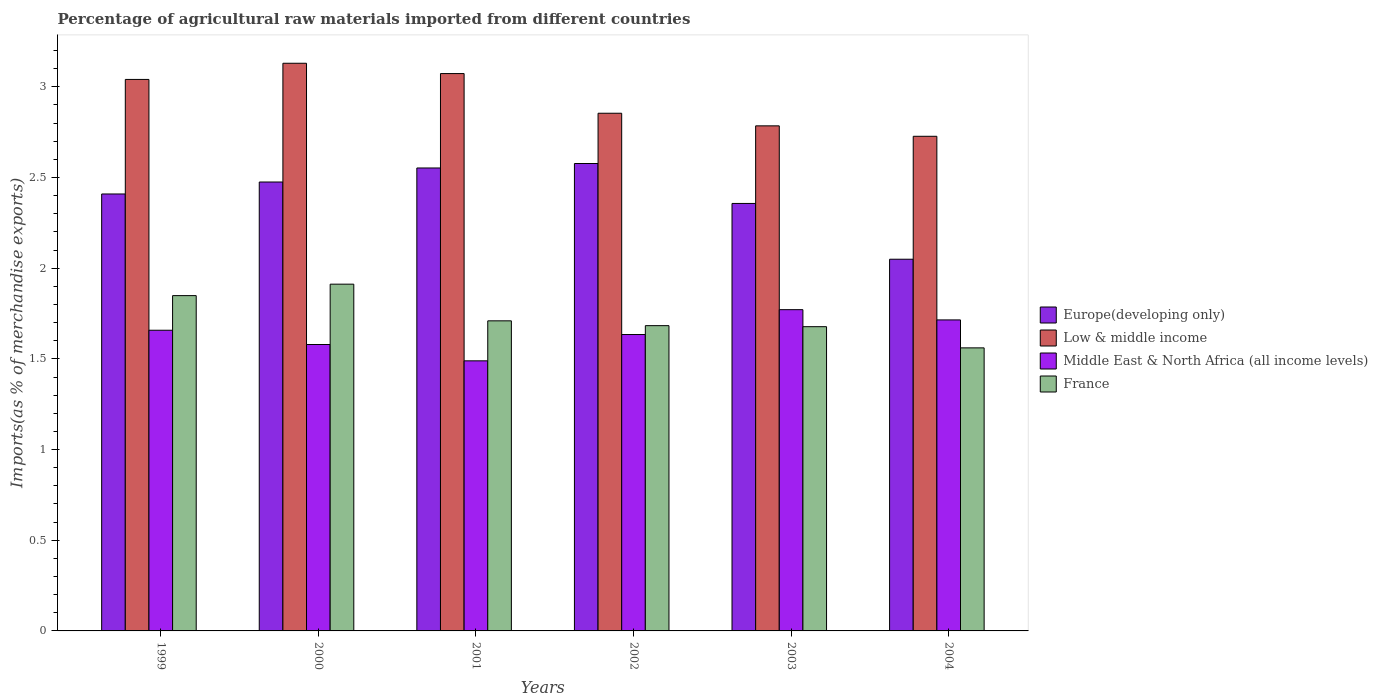Are the number of bars on each tick of the X-axis equal?
Provide a succinct answer. Yes. How many bars are there on the 5th tick from the left?
Keep it short and to the point. 4. How many bars are there on the 3rd tick from the right?
Give a very brief answer. 4. What is the label of the 3rd group of bars from the left?
Provide a short and direct response. 2001. In how many cases, is the number of bars for a given year not equal to the number of legend labels?
Make the answer very short. 0. What is the percentage of imports to different countries in Low & middle income in 2001?
Give a very brief answer. 3.07. Across all years, what is the maximum percentage of imports to different countries in Middle East & North Africa (all income levels)?
Provide a short and direct response. 1.77. Across all years, what is the minimum percentage of imports to different countries in Europe(developing only)?
Provide a short and direct response. 2.05. In which year was the percentage of imports to different countries in France maximum?
Make the answer very short. 2000. In which year was the percentage of imports to different countries in Middle East & North Africa (all income levels) minimum?
Ensure brevity in your answer.  2001. What is the total percentage of imports to different countries in France in the graph?
Provide a short and direct response. 10.39. What is the difference between the percentage of imports to different countries in Low & middle income in 2000 and that in 2001?
Give a very brief answer. 0.06. What is the difference between the percentage of imports to different countries in Europe(developing only) in 2001 and the percentage of imports to different countries in Low & middle income in 2004?
Your response must be concise. -0.17. What is the average percentage of imports to different countries in Low & middle income per year?
Your response must be concise. 2.93. In the year 2003, what is the difference between the percentage of imports to different countries in Middle East & North Africa (all income levels) and percentage of imports to different countries in Europe(developing only)?
Give a very brief answer. -0.59. In how many years, is the percentage of imports to different countries in Low & middle income greater than 2.2 %?
Your answer should be compact. 6. What is the ratio of the percentage of imports to different countries in Middle East & North Africa (all income levels) in 2001 to that in 2003?
Give a very brief answer. 0.84. Is the percentage of imports to different countries in Europe(developing only) in 2000 less than that in 2002?
Your answer should be very brief. Yes. Is the difference between the percentage of imports to different countries in Middle East & North Africa (all income levels) in 1999 and 2000 greater than the difference between the percentage of imports to different countries in Europe(developing only) in 1999 and 2000?
Offer a very short reply. Yes. What is the difference between the highest and the second highest percentage of imports to different countries in France?
Keep it short and to the point. 0.06. What is the difference between the highest and the lowest percentage of imports to different countries in Low & middle income?
Offer a terse response. 0.4. What does the 4th bar from the left in 2001 represents?
Your answer should be very brief. France. Are all the bars in the graph horizontal?
Provide a short and direct response. No. How many years are there in the graph?
Offer a very short reply. 6. What is the difference between two consecutive major ticks on the Y-axis?
Provide a short and direct response. 0.5. Are the values on the major ticks of Y-axis written in scientific E-notation?
Ensure brevity in your answer.  No. Does the graph contain grids?
Offer a very short reply. No. Where does the legend appear in the graph?
Provide a short and direct response. Center right. How are the legend labels stacked?
Keep it short and to the point. Vertical. What is the title of the graph?
Provide a short and direct response. Percentage of agricultural raw materials imported from different countries. Does "Jamaica" appear as one of the legend labels in the graph?
Provide a succinct answer. No. What is the label or title of the X-axis?
Your response must be concise. Years. What is the label or title of the Y-axis?
Give a very brief answer. Imports(as % of merchandise exports). What is the Imports(as % of merchandise exports) in Europe(developing only) in 1999?
Offer a very short reply. 2.41. What is the Imports(as % of merchandise exports) of Low & middle income in 1999?
Your response must be concise. 3.04. What is the Imports(as % of merchandise exports) of Middle East & North Africa (all income levels) in 1999?
Ensure brevity in your answer.  1.66. What is the Imports(as % of merchandise exports) in France in 1999?
Make the answer very short. 1.85. What is the Imports(as % of merchandise exports) of Europe(developing only) in 2000?
Offer a very short reply. 2.48. What is the Imports(as % of merchandise exports) of Low & middle income in 2000?
Make the answer very short. 3.13. What is the Imports(as % of merchandise exports) of Middle East & North Africa (all income levels) in 2000?
Offer a very short reply. 1.58. What is the Imports(as % of merchandise exports) in France in 2000?
Your answer should be very brief. 1.91. What is the Imports(as % of merchandise exports) of Europe(developing only) in 2001?
Offer a terse response. 2.55. What is the Imports(as % of merchandise exports) in Low & middle income in 2001?
Ensure brevity in your answer.  3.07. What is the Imports(as % of merchandise exports) of Middle East & North Africa (all income levels) in 2001?
Ensure brevity in your answer.  1.49. What is the Imports(as % of merchandise exports) in France in 2001?
Provide a succinct answer. 1.71. What is the Imports(as % of merchandise exports) in Europe(developing only) in 2002?
Keep it short and to the point. 2.58. What is the Imports(as % of merchandise exports) of Low & middle income in 2002?
Keep it short and to the point. 2.85. What is the Imports(as % of merchandise exports) of Middle East & North Africa (all income levels) in 2002?
Your response must be concise. 1.63. What is the Imports(as % of merchandise exports) in France in 2002?
Provide a short and direct response. 1.68. What is the Imports(as % of merchandise exports) of Europe(developing only) in 2003?
Make the answer very short. 2.36. What is the Imports(as % of merchandise exports) in Low & middle income in 2003?
Offer a terse response. 2.78. What is the Imports(as % of merchandise exports) in Middle East & North Africa (all income levels) in 2003?
Offer a very short reply. 1.77. What is the Imports(as % of merchandise exports) in France in 2003?
Give a very brief answer. 1.68. What is the Imports(as % of merchandise exports) in Europe(developing only) in 2004?
Provide a short and direct response. 2.05. What is the Imports(as % of merchandise exports) in Low & middle income in 2004?
Your response must be concise. 2.73. What is the Imports(as % of merchandise exports) of Middle East & North Africa (all income levels) in 2004?
Ensure brevity in your answer.  1.71. What is the Imports(as % of merchandise exports) in France in 2004?
Make the answer very short. 1.56. Across all years, what is the maximum Imports(as % of merchandise exports) in Europe(developing only)?
Your answer should be compact. 2.58. Across all years, what is the maximum Imports(as % of merchandise exports) in Low & middle income?
Provide a succinct answer. 3.13. Across all years, what is the maximum Imports(as % of merchandise exports) in Middle East & North Africa (all income levels)?
Your response must be concise. 1.77. Across all years, what is the maximum Imports(as % of merchandise exports) of France?
Your response must be concise. 1.91. Across all years, what is the minimum Imports(as % of merchandise exports) of Europe(developing only)?
Ensure brevity in your answer.  2.05. Across all years, what is the minimum Imports(as % of merchandise exports) in Low & middle income?
Your answer should be compact. 2.73. Across all years, what is the minimum Imports(as % of merchandise exports) in Middle East & North Africa (all income levels)?
Offer a terse response. 1.49. Across all years, what is the minimum Imports(as % of merchandise exports) in France?
Offer a very short reply. 1.56. What is the total Imports(as % of merchandise exports) of Europe(developing only) in the graph?
Provide a succinct answer. 14.42. What is the total Imports(as % of merchandise exports) in Low & middle income in the graph?
Your answer should be very brief. 17.61. What is the total Imports(as % of merchandise exports) in Middle East & North Africa (all income levels) in the graph?
Offer a very short reply. 9.85. What is the total Imports(as % of merchandise exports) of France in the graph?
Your response must be concise. 10.39. What is the difference between the Imports(as % of merchandise exports) of Europe(developing only) in 1999 and that in 2000?
Keep it short and to the point. -0.07. What is the difference between the Imports(as % of merchandise exports) in Low & middle income in 1999 and that in 2000?
Your response must be concise. -0.09. What is the difference between the Imports(as % of merchandise exports) of Middle East & North Africa (all income levels) in 1999 and that in 2000?
Provide a short and direct response. 0.08. What is the difference between the Imports(as % of merchandise exports) in France in 1999 and that in 2000?
Give a very brief answer. -0.06. What is the difference between the Imports(as % of merchandise exports) of Europe(developing only) in 1999 and that in 2001?
Offer a very short reply. -0.14. What is the difference between the Imports(as % of merchandise exports) of Low & middle income in 1999 and that in 2001?
Your response must be concise. -0.03. What is the difference between the Imports(as % of merchandise exports) in Middle East & North Africa (all income levels) in 1999 and that in 2001?
Your answer should be compact. 0.17. What is the difference between the Imports(as % of merchandise exports) of France in 1999 and that in 2001?
Keep it short and to the point. 0.14. What is the difference between the Imports(as % of merchandise exports) in Europe(developing only) in 1999 and that in 2002?
Make the answer very short. -0.17. What is the difference between the Imports(as % of merchandise exports) of Low & middle income in 1999 and that in 2002?
Your answer should be very brief. 0.19. What is the difference between the Imports(as % of merchandise exports) of Middle East & North Africa (all income levels) in 1999 and that in 2002?
Offer a terse response. 0.02. What is the difference between the Imports(as % of merchandise exports) of France in 1999 and that in 2002?
Keep it short and to the point. 0.17. What is the difference between the Imports(as % of merchandise exports) of Europe(developing only) in 1999 and that in 2003?
Keep it short and to the point. 0.05. What is the difference between the Imports(as % of merchandise exports) of Low & middle income in 1999 and that in 2003?
Provide a succinct answer. 0.26. What is the difference between the Imports(as % of merchandise exports) in Middle East & North Africa (all income levels) in 1999 and that in 2003?
Keep it short and to the point. -0.11. What is the difference between the Imports(as % of merchandise exports) of France in 1999 and that in 2003?
Keep it short and to the point. 0.17. What is the difference between the Imports(as % of merchandise exports) of Europe(developing only) in 1999 and that in 2004?
Ensure brevity in your answer.  0.36. What is the difference between the Imports(as % of merchandise exports) of Low & middle income in 1999 and that in 2004?
Your answer should be very brief. 0.31. What is the difference between the Imports(as % of merchandise exports) of Middle East & North Africa (all income levels) in 1999 and that in 2004?
Ensure brevity in your answer.  -0.06. What is the difference between the Imports(as % of merchandise exports) in France in 1999 and that in 2004?
Give a very brief answer. 0.29. What is the difference between the Imports(as % of merchandise exports) of Europe(developing only) in 2000 and that in 2001?
Ensure brevity in your answer.  -0.08. What is the difference between the Imports(as % of merchandise exports) of Low & middle income in 2000 and that in 2001?
Your response must be concise. 0.06. What is the difference between the Imports(as % of merchandise exports) in Middle East & North Africa (all income levels) in 2000 and that in 2001?
Offer a very short reply. 0.09. What is the difference between the Imports(as % of merchandise exports) of France in 2000 and that in 2001?
Your response must be concise. 0.2. What is the difference between the Imports(as % of merchandise exports) in Europe(developing only) in 2000 and that in 2002?
Keep it short and to the point. -0.1. What is the difference between the Imports(as % of merchandise exports) of Low & middle income in 2000 and that in 2002?
Make the answer very short. 0.28. What is the difference between the Imports(as % of merchandise exports) in Middle East & North Africa (all income levels) in 2000 and that in 2002?
Your answer should be compact. -0.06. What is the difference between the Imports(as % of merchandise exports) in France in 2000 and that in 2002?
Your answer should be compact. 0.23. What is the difference between the Imports(as % of merchandise exports) of Europe(developing only) in 2000 and that in 2003?
Your answer should be very brief. 0.12. What is the difference between the Imports(as % of merchandise exports) of Low & middle income in 2000 and that in 2003?
Provide a short and direct response. 0.35. What is the difference between the Imports(as % of merchandise exports) of Middle East & North Africa (all income levels) in 2000 and that in 2003?
Provide a succinct answer. -0.19. What is the difference between the Imports(as % of merchandise exports) in France in 2000 and that in 2003?
Your answer should be compact. 0.23. What is the difference between the Imports(as % of merchandise exports) of Europe(developing only) in 2000 and that in 2004?
Your answer should be compact. 0.43. What is the difference between the Imports(as % of merchandise exports) of Low & middle income in 2000 and that in 2004?
Provide a succinct answer. 0.4. What is the difference between the Imports(as % of merchandise exports) in Middle East & North Africa (all income levels) in 2000 and that in 2004?
Make the answer very short. -0.14. What is the difference between the Imports(as % of merchandise exports) of France in 2000 and that in 2004?
Offer a very short reply. 0.35. What is the difference between the Imports(as % of merchandise exports) of Europe(developing only) in 2001 and that in 2002?
Your answer should be compact. -0.02. What is the difference between the Imports(as % of merchandise exports) in Low & middle income in 2001 and that in 2002?
Make the answer very short. 0.22. What is the difference between the Imports(as % of merchandise exports) of Middle East & North Africa (all income levels) in 2001 and that in 2002?
Offer a very short reply. -0.15. What is the difference between the Imports(as % of merchandise exports) of France in 2001 and that in 2002?
Keep it short and to the point. 0.03. What is the difference between the Imports(as % of merchandise exports) in Europe(developing only) in 2001 and that in 2003?
Offer a terse response. 0.2. What is the difference between the Imports(as % of merchandise exports) of Low & middle income in 2001 and that in 2003?
Provide a succinct answer. 0.29. What is the difference between the Imports(as % of merchandise exports) in Middle East & North Africa (all income levels) in 2001 and that in 2003?
Your answer should be very brief. -0.28. What is the difference between the Imports(as % of merchandise exports) in France in 2001 and that in 2003?
Your answer should be compact. 0.03. What is the difference between the Imports(as % of merchandise exports) of Europe(developing only) in 2001 and that in 2004?
Your response must be concise. 0.5. What is the difference between the Imports(as % of merchandise exports) of Low & middle income in 2001 and that in 2004?
Offer a terse response. 0.35. What is the difference between the Imports(as % of merchandise exports) of Middle East & North Africa (all income levels) in 2001 and that in 2004?
Provide a short and direct response. -0.23. What is the difference between the Imports(as % of merchandise exports) of France in 2001 and that in 2004?
Give a very brief answer. 0.15. What is the difference between the Imports(as % of merchandise exports) of Europe(developing only) in 2002 and that in 2003?
Offer a very short reply. 0.22. What is the difference between the Imports(as % of merchandise exports) in Low & middle income in 2002 and that in 2003?
Offer a terse response. 0.07. What is the difference between the Imports(as % of merchandise exports) in Middle East & North Africa (all income levels) in 2002 and that in 2003?
Offer a very short reply. -0.14. What is the difference between the Imports(as % of merchandise exports) in France in 2002 and that in 2003?
Ensure brevity in your answer.  0.01. What is the difference between the Imports(as % of merchandise exports) in Europe(developing only) in 2002 and that in 2004?
Provide a succinct answer. 0.53. What is the difference between the Imports(as % of merchandise exports) in Low & middle income in 2002 and that in 2004?
Offer a very short reply. 0.13. What is the difference between the Imports(as % of merchandise exports) in Middle East & North Africa (all income levels) in 2002 and that in 2004?
Your response must be concise. -0.08. What is the difference between the Imports(as % of merchandise exports) of France in 2002 and that in 2004?
Ensure brevity in your answer.  0.12. What is the difference between the Imports(as % of merchandise exports) in Europe(developing only) in 2003 and that in 2004?
Your response must be concise. 0.31. What is the difference between the Imports(as % of merchandise exports) in Low & middle income in 2003 and that in 2004?
Provide a short and direct response. 0.06. What is the difference between the Imports(as % of merchandise exports) of Middle East & North Africa (all income levels) in 2003 and that in 2004?
Provide a succinct answer. 0.06. What is the difference between the Imports(as % of merchandise exports) of France in 2003 and that in 2004?
Your answer should be compact. 0.12. What is the difference between the Imports(as % of merchandise exports) of Europe(developing only) in 1999 and the Imports(as % of merchandise exports) of Low & middle income in 2000?
Your response must be concise. -0.72. What is the difference between the Imports(as % of merchandise exports) in Europe(developing only) in 1999 and the Imports(as % of merchandise exports) in Middle East & North Africa (all income levels) in 2000?
Keep it short and to the point. 0.83. What is the difference between the Imports(as % of merchandise exports) in Europe(developing only) in 1999 and the Imports(as % of merchandise exports) in France in 2000?
Provide a succinct answer. 0.5. What is the difference between the Imports(as % of merchandise exports) in Low & middle income in 1999 and the Imports(as % of merchandise exports) in Middle East & North Africa (all income levels) in 2000?
Your answer should be very brief. 1.46. What is the difference between the Imports(as % of merchandise exports) in Low & middle income in 1999 and the Imports(as % of merchandise exports) in France in 2000?
Offer a terse response. 1.13. What is the difference between the Imports(as % of merchandise exports) of Middle East & North Africa (all income levels) in 1999 and the Imports(as % of merchandise exports) of France in 2000?
Provide a succinct answer. -0.25. What is the difference between the Imports(as % of merchandise exports) of Europe(developing only) in 1999 and the Imports(as % of merchandise exports) of Low & middle income in 2001?
Offer a terse response. -0.66. What is the difference between the Imports(as % of merchandise exports) in Europe(developing only) in 1999 and the Imports(as % of merchandise exports) in Middle East & North Africa (all income levels) in 2001?
Your answer should be compact. 0.92. What is the difference between the Imports(as % of merchandise exports) in Europe(developing only) in 1999 and the Imports(as % of merchandise exports) in France in 2001?
Your answer should be very brief. 0.7. What is the difference between the Imports(as % of merchandise exports) of Low & middle income in 1999 and the Imports(as % of merchandise exports) of Middle East & North Africa (all income levels) in 2001?
Offer a very short reply. 1.55. What is the difference between the Imports(as % of merchandise exports) of Low & middle income in 1999 and the Imports(as % of merchandise exports) of France in 2001?
Give a very brief answer. 1.33. What is the difference between the Imports(as % of merchandise exports) of Middle East & North Africa (all income levels) in 1999 and the Imports(as % of merchandise exports) of France in 2001?
Provide a succinct answer. -0.05. What is the difference between the Imports(as % of merchandise exports) of Europe(developing only) in 1999 and the Imports(as % of merchandise exports) of Low & middle income in 2002?
Provide a succinct answer. -0.45. What is the difference between the Imports(as % of merchandise exports) of Europe(developing only) in 1999 and the Imports(as % of merchandise exports) of Middle East & North Africa (all income levels) in 2002?
Provide a succinct answer. 0.77. What is the difference between the Imports(as % of merchandise exports) of Europe(developing only) in 1999 and the Imports(as % of merchandise exports) of France in 2002?
Keep it short and to the point. 0.73. What is the difference between the Imports(as % of merchandise exports) of Low & middle income in 1999 and the Imports(as % of merchandise exports) of Middle East & North Africa (all income levels) in 2002?
Keep it short and to the point. 1.41. What is the difference between the Imports(as % of merchandise exports) of Low & middle income in 1999 and the Imports(as % of merchandise exports) of France in 2002?
Offer a terse response. 1.36. What is the difference between the Imports(as % of merchandise exports) in Middle East & North Africa (all income levels) in 1999 and the Imports(as % of merchandise exports) in France in 2002?
Make the answer very short. -0.03. What is the difference between the Imports(as % of merchandise exports) of Europe(developing only) in 1999 and the Imports(as % of merchandise exports) of Low & middle income in 2003?
Ensure brevity in your answer.  -0.38. What is the difference between the Imports(as % of merchandise exports) of Europe(developing only) in 1999 and the Imports(as % of merchandise exports) of Middle East & North Africa (all income levels) in 2003?
Keep it short and to the point. 0.64. What is the difference between the Imports(as % of merchandise exports) in Europe(developing only) in 1999 and the Imports(as % of merchandise exports) in France in 2003?
Your answer should be very brief. 0.73. What is the difference between the Imports(as % of merchandise exports) in Low & middle income in 1999 and the Imports(as % of merchandise exports) in Middle East & North Africa (all income levels) in 2003?
Offer a very short reply. 1.27. What is the difference between the Imports(as % of merchandise exports) in Low & middle income in 1999 and the Imports(as % of merchandise exports) in France in 2003?
Provide a short and direct response. 1.36. What is the difference between the Imports(as % of merchandise exports) of Middle East & North Africa (all income levels) in 1999 and the Imports(as % of merchandise exports) of France in 2003?
Your answer should be compact. -0.02. What is the difference between the Imports(as % of merchandise exports) of Europe(developing only) in 1999 and the Imports(as % of merchandise exports) of Low & middle income in 2004?
Provide a succinct answer. -0.32. What is the difference between the Imports(as % of merchandise exports) in Europe(developing only) in 1999 and the Imports(as % of merchandise exports) in Middle East & North Africa (all income levels) in 2004?
Give a very brief answer. 0.69. What is the difference between the Imports(as % of merchandise exports) in Europe(developing only) in 1999 and the Imports(as % of merchandise exports) in France in 2004?
Provide a succinct answer. 0.85. What is the difference between the Imports(as % of merchandise exports) of Low & middle income in 1999 and the Imports(as % of merchandise exports) of Middle East & North Africa (all income levels) in 2004?
Offer a very short reply. 1.33. What is the difference between the Imports(as % of merchandise exports) of Low & middle income in 1999 and the Imports(as % of merchandise exports) of France in 2004?
Offer a terse response. 1.48. What is the difference between the Imports(as % of merchandise exports) of Middle East & North Africa (all income levels) in 1999 and the Imports(as % of merchandise exports) of France in 2004?
Provide a short and direct response. 0.1. What is the difference between the Imports(as % of merchandise exports) in Europe(developing only) in 2000 and the Imports(as % of merchandise exports) in Low & middle income in 2001?
Your answer should be very brief. -0.6. What is the difference between the Imports(as % of merchandise exports) of Europe(developing only) in 2000 and the Imports(as % of merchandise exports) of Middle East & North Africa (all income levels) in 2001?
Provide a succinct answer. 0.99. What is the difference between the Imports(as % of merchandise exports) of Europe(developing only) in 2000 and the Imports(as % of merchandise exports) of France in 2001?
Your answer should be very brief. 0.77. What is the difference between the Imports(as % of merchandise exports) in Low & middle income in 2000 and the Imports(as % of merchandise exports) in Middle East & North Africa (all income levels) in 2001?
Provide a succinct answer. 1.64. What is the difference between the Imports(as % of merchandise exports) in Low & middle income in 2000 and the Imports(as % of merchandise exports) in France in 2001?
Keep it short and to the point. 1.42. What is the difference between the Imports(as % of merchandise exports) of Middle East & North Africa (all income levels) in 2000 and the Imports(as % of merchandise exports) of France in 2001?
Provide a succinct answer. -0.13. What is the difference between the Imports(as % of merchandise exports) in Europe(developing only) in 2000 and the Imports(as % of merchandise exports) in Low & middle income in 2002?
Give a very brief answer. -0.38. What is the difference between the Imports(as % of merchandise exports) in Europe(developing only) in 2000 and the Imports(as % of merchandise exports) in Middle East & North Africa (all income levels) in 2002?
Offer a terse response. 0.84. What is the difference between the Imports(as % of merchandise exports) of Europe(developing only) in 2000 and the Imports(as % of merchandise exports) of France in 2002?
Your answer should be very brief. 0.79. What is the difference between the Imports(as % of merchandise exports) in Low & middle income in 2000 and the Imports(as % of merchandise exports) in Middle East & North Africa (all income levels) in 2002?
Your answer should be very brief. 1.5. What is the difference between the Imports(as % of merchandise exports) of Low & middle income in 2000 and the Imports(as % of merchandise exports) of France in 2002?
Your answer should be compact. 1.45. What is the difference between the Imports(as % of merchandise exports) in Middle East & North Africa (all income levels) in 2000 and the Imports(as % of merchandise exports) in France in 2002?
Provide a succinct answer. -0.1. What is the difference between the Imports(as % of merchandise exports) in Europe(developing only) in 2000 and the Imports(as % of merchandise exports) in Low & middle income in 2003?
Your answer should be compact. -0.31. What is the difference between the Imports(as % of merchandise exports) of Europe(developing only) in 2000 and the Imports(as % of merchandise exports) of Middle East & North Africa (all income levels) in 2003?
Offer a terse response. 0.7. What is the difference between the Imports(as % of merchandise exports) in Europe(developing only) in 2000 and the Imports(as % of merchandise exports) in France in 2003?
Your response must be concise. 0.8. What is the difference between the Imports(as % of merchandise exports) of Low & middle income in 2000 and the Imports(as % of merchandise exports) of Middle East & North Africa (all income levels) in 2003?
Your response must be concise. 1.36. What is the difference between the Imports(as % of merchandise exports) of Low & middle income in 2000 and the Imports(as % of merchandise exports) of France in 2003?
Make the answer very short. 1.45. What is the difference between the Imports(as % of merchandise exports) of Middle East & North Africa (all income levels) in 2000 and the Imports(as % of merchandise exports) of France in 2003?
Offer a terse response. -0.1. What is the difference between the Imports(as % of merchandise exports) of Europe(developing only) in 2000 and the Imports(as % of merchandise exports) of Low & middle income in 2004?
Ensure brevity in your answer.  -0.25. What is the difference between the Imports(as % of merchandise exports) in Europe(developing only) in 2000 and the Imports(as % of merchandise exports) in Middle East & North Africa (all income levels) in 2004?
Give a very brief answer. 0.76. What is the difference between the Imports(as % of merchandise exports) in Europe(developing only) in 2000 and the Imports(as % of merchandise exports) in France in 2004?
Give a very brief answer. 0.91. What is the difference between the Imports(as % of merchandise exports) in Low & middle income in 2000 and the Imports(as % of merchandise exports) in Middle East & North Africa (all income levels) in 2004?
Keep it short and to the point. 1.42. What is the difference between the Imports(as % of merchandise exports) of Low & middle income in 2000 and the Imports(as % of merchandise exports) of France in 2004?
Offer a very short reply. 1.57. What is the difference between the Imports(as % of merchandise exports) of Middle East & North Africa (all income levels) in 2000 and the Imports(as % of merchandise exports) of France in 2004?
Ensure brevity in your answer.  0.02. What is the difference between the Imports(as % of merchandise exports) in Europe(developing only) in 2001 and the Imports(as % of merchandise exports) in Low & middle income in 2002?
Provide a short and direct response. -0.3. What is the difference between the Imports(as % of merchandise exports) in Europe(developing only) in 2001 and the Imports(as % of merchandise exports) in Middle East & North Africa (all income levels) in 2002?
Your answer should be compact. 0.92. What is the difference between the Imports(as % of merchandise exports) of Europe(developing only) in 2001 and the Imports(as % of merchandise exports) of France in 2002?
Your response must be concise. 0.87. What is the difference between the Imports(as % of merchandise exports) in Low & middle income in 2001 and the Imports(as % of merchandise exports) in Middle East & North Africa (all income levels) in 2002?
Keep it short and to the point. 1.44. What is the difference between the Imports(as % of merchandise exports) of Low & middle income in 2001 and the Imports(as % of merchandise exports) of France in 2002?
Provide a short and direct response. 1.39. What is the difference between the Imports(as % of merchandise exports) of Middle East & North Africa (all income levels) in 2001 and the Imports(as % of merchandise exports) of France in 2002?
Ensure brevity in your answer.  -0.19. What is the difference between the Imports(as % of merchandise exports) of Europe(developing only) in 2001 and the Imports(as % of merchandise exports) of Low & middle income in 2003?
Offer a very short reply. -0.23. What is the difference between the Imports(as % of merchandise exports) of Europe(developing only) in 2001 and the Imports(as % of merchandise exports) of Middle East & North Africa (all income levels) in 2003?
Keep it short and to the point. 0.78. What is the difference between the Imports(as % of merchandise exports) in Low & middle income in 2001 and the Imports(as % of merchandise exports) in Middle East & North Africa (all income levels) in 2003?
Your answer should be very brief. 1.3. What is the difference between the Imports(as % of merchandise exports) of Low & middle income in 2001 and the Imports(as % of merchandise exports) of France in 2003?
Keep it short and to the point. 1.4. What is the difference between the Imports(as % of merchandise exports) of Middle East & North Africa (all income levels) in 2001 and the Imports(as % of merchandise exports) of France in 2003?
Keep it short and to the point. -0.19. What is the difference between the Imports(as % of merchandise exports) of Europe(developing only) in 2001 and the Imports(as % of merchandise exports) of Low & middle income in 2004?
Make the answer very short. -0.17. What is the difference between the Imports(as % of merchandise exports) of Europe(developing only) in 2001 and the Imports(as % of merchandise exports) of Middle East & North Africa (all income levels) in 2004?
Your answer should be compact. 0.84. What is the difference between the Imports(as % of merchandise exports) of Europe(developing only) in 2001 and the Imports(as % of merchandise exports) of France in 2004?
Provide a short and direct response. 0.99. What is the difference between the Imports(as % of merchandise exports) of Low & middle income in 2001 and the Imports(as % of merchandise exports) of Middle East & North Africa (all income levels) in 2004?
Provide a short and direct response. 1.36. What is the difference between the Imports(as % of merchandise exports) of Low & middle income in 2001 and the Imports(as % of merchandise exports) of France in 2004?
Ensure brevity in your answer.  1.51. What is the difference between the Imports(as % of merchandise exports) of Middle East & North Africa (all income levels) in 2001 and the Imports(as % of merchandise exports) of France in 2004?
Make the answer very short. -0.07. What is the difference between the Imports(as % of merchandise exports) in Europe(developing only) in 2002 and the Imports(as % of merchandise exports) in Low & middle income in 2003?
Provide a short and direct response. -0.21. What is the difference between the Imports(as % of merchandise exports) of Europe(developing only) in 2002 and the Imports(as % of merchandise exports) of Middle East & North Africa (all income levels) in 2003?
Keep it short and to the point. 0.81. What is the difference between the Imports(as % of merchandise exports) of Europe(developing only) in 2002 and the Imports(as % of merchandise exports) of France in 2003?
Offer a very short reply. 0.9. What is the difference between the Imports(as % of merchandise exports) in Low & middle income in 2002 and the Imports(as % of merchandise exports) in Middle East & North Africa (all income levels) in 2003?
Keep it short and to the point. 1.08. What is the difference between the Imports(as % of merchandise exports) in Low & middle income in 2002 and the Imports(as % of merchandise exports) in France in 2003?
Provide a short and direct response. 1.18. What is the difference between the Imports(as % of merchandise exports) in Middle East & North Africa (all income levels) in 2002 and the Imports(as % of merchandise exports) in France in 2003?
Keep it short and to the point. -0.04. What is the difference between the Imports(as % of merchandise exports) in Europe(developing only) in 2002 and the Imports(as % of merchandise exports) in Low & middle income in 2004?
Your answer should be compact. -0.15. What is the difference between the Imports(as % of merchandise exports) of Europe(developing only) in 2002 and the Imports(as % of merchandise exports) of Middle East & North Africa (all income levels) in 2004?
Ensure brevity in your answer.  0.86. What is the difference between the Imports(as % of merchandise exports) in Europe(developing only) in 2002 and the Imports(as % of merchandise exports) in France in 2004?
Your answer should be very brief. 1.02. What is the difference between the Imports(as % of merchandise exports) in Low & middle income in 2002 and the Imports(as % of merchandise exports) in Middle East & North Africa (all income levels) in 2004?
Ensure brevity in your answer.  1.14. What is the difference between the Imports(as % of merchandise exports) in Low & middle income in 2002 and the Imports(as % of merchandise exports) in France in 2004?
Offer a very short reply. 1.29. What is the difference between the Imports(as % of merchandise exports) of Middle East & North Africa (all income levels) in 2002 and the Imports(as % of merchandise exports) of France in 2004?
Offer a very short reply. 0.07. What is the difference between the Imports(as % of merchandise exports) in Europe(developing only) in 2003 and the Imports(as % of merchandise exports) in Low & middle income in 2004?
Your response must be concise. -0.37. What is the difference between the Imports(as % of merchandise exports) in Europe(developing only) in 2003 and the Imports(as % of merchandise exports) in Middle East & North Africa (all income levels) in 2004?
Keep it short and to the point. 0.64. What is the difference between the Imports(as % of merchandise exports) in Europe(developing only) in 2003 and the Imports(as % of merchandise exports) in France in 2004?
Your answer should be very brief. 0.8. What is the difference between the Imports(as % of merchandise exports) of Low & middle income in 2003 and the Imports(as % of merchandise exports) of Middle East & North Africa (all income levels) in 2004?
Provide a short and direct response. 1.07. What is the difference between the Imports(as % of merchandise exports) of Low & middle income in 2003 and the Imports(as % of merchandise exports) of France in 2004?
Keep it short and to the point. 1.22. What is the difference between the Imports(as % of merchandise exports) in Middle East & North Africa (all income levels) in 2003 and the Imports(as % of merchandise exports) in France in 2004?
Offer a terse response. 0.21. What is the average Imports(as % of merchandise exports) in Europe(developing only) per year?
Ensure brevity in your answer.  2.4. What is the average Imports(as % of merchandise exports) in Low & middle income per year?
Your answer should be very brief. 2.94. What is the average Imports(as % of merchandise exports) of Middle East & North Africa (all income levels) per year?
Your response must be concise. 1.64. What is the average Imports(as % of merchandise exports) of France per year?
Your response must be concise. 1.73. In the year 1999, what is the difference between the Imports(as % of merchandise exports) of Europe(developing only) and Imports(as % of merchandise exports) of Low & middle income?
Give a very brief answer. -0.63. In the year 1999, what is the difference between the Imports(as % of merchandise exports) in Europe(developing only) and Imports(as % of merchandise exports) in Middle East & North Africa (all income levels)?
Your response must be concise. 0.75. In the year 1999, what is the difference between the Imports(as % of merchandise exports) of Europe(developing only) and Imports(as % of merchandise exports) of France?
Your response must be concise. 0.56. In the year 1999, what is the difference between the Imports(as % of merchandise exports) of Low & middle income and Imports(as % of merchandise exports) of Middle East & North Africa (all income levels)?
Your answer should be compact. 1.38. In the year 1999, what is the difference between the Imports(as % of merchandise exports) of Low & middle income and Imports(as % of merchandise exports) of France?
Offer a very short reply. 1.19. In the year 1999, what is the difference between the Imports(as % of merchandise exports) of Middle East & North Africa (all income levels) and Imports(as % of merchandise exports) of France?
Give a very brief answer. -0.19. In the year 2000, what is the difference between the Imports(as % of merchandise exports) of Europe(developing only) and Imports(as % of merchandise exports) of Low & middle income?
Give a very brief answer. -0.65. In the year 2000, what is the difference between the Imports(as % of merchandise exports) in Europe(developing only) and Imports(as % of merchandise exports) in Middle East & North Africa (all income levels)?
Give a very brief answer. 0.9. In the year 2000, what is the difference between the Imports(as % of merchandise exports) in Europe(developing only) and Imports(as % of merchandise exports) in France?
Ensure brevity in your answer.  0.56. In the year 2000, what is the difference between the Imports(as % of merchandise exports) of Low & middle income and Imports(as % of merchandise exports) of Middle East & North Africa (all income levels)?
Keep it short and to the point. 1.55. In the year 2000, what is the difference between the Imports(as % of merchandise exports) of Low & middle income and Imports(as % of merchandise exports) of France?
Your answer should be compact. 1.22. In the year 2000, what is the difference between the Imports(as % of merchandise exports) in Middle East & North Africa (all income levels) and Imports(as % of merchandise exports) in France?
Offer a very short reply. -0.33. In the year 2001, what is the difference between the Imports(as % of merchandise exports) in Europe(developing only) and Imports(as % of merchandise exports) in Low & middle income?
Provide a short and direct response. -0.52. In the year 2001, what is the difference between the Imports(as % of merchandise exports) of Europe(developing only) and Imports(as % of merchandise exports) of Middle East & North Africa (all income levels)?
Provide a short and direct response. 1.06. In the year 2001, what is the difference between the Imports(as % of merchandise exports) of Europe(developing only) and Imports(as % of merchandise exports) of France?
Your answer should be very brief. 0.84. In the year 2001, what is the difference between the Imports(as % of merchandise exports) of Low & middle income and Imports(as % of merchandise exports) of Middle East & North Africa (all income levels)?
Your response must be concise. 1.58. In the year 2001, what is the difference between the Imports(as % of merchandise exports) of Low & middle income and Imports(as % of merchandise exports) of France?
Your response must be concise. 1.36. In the year 2001, what is the difference between the Imports(as % of merchandise exports) of Middle East & North Africa (all income levels) and Imports(as % of merchandise exports) of France?
Offer a terse response. -0.22. In the year 2002, what is the difference between the Imports(as % of merchandise exports) of Europe(developing only) and Imports(as % of merchandise exports) of Low & middle income?
Your response must be concise. -0.28. In the year 2002, what is the difference between the Imports(as % of merchandise exports) of Europe(developing only) and Imports(as % of merchandise exports) of Middle East & North Africa (all income levels)?
Your answer should be compact. 0.94. In the year 2002, what is the difference between the Imports(as % of merchandise exports) of Europe(developing only) and Imports(as % of merchandise exports) of France?
Provide a succinct answer. 0.89. In the year 2002, what is the difference between the Imports(as % of merchandise exports) of Low & middle income and Imports(as % of merchandise exports) of Middle East & North Africa (all income levels)?
Ensure brevity in your answer.  1.22. In the year 2002, what is the difference between the Imports(as % of merchandise exports) in Low & middle income and Imports(as % of merchandise exports) in France?
Make the answer very short. 1.17. In the year 2002, what is the difference between the Imports(as % of merchandise exports) of Middle East & North Africa (all income levels) and Imports(as % of merchandise exports) of France?
Your answer should be compact. -0.05. In the year 2003, what is the difference between the Imports(as % of merchandise exports) in Europe(developing only) and Imports(as % of merchandise exports) in Low & middle income?
Offer a terse response. -0.43. In the year 2003, what is the difference between the Imports(as % of merchandise exports) in Europe(developing only) and Imports(as % of merchandise exports) in Middle East & North Africa (all income levels)?
Your answer should be compact. 0.59. In the year 2003, what is the difference between the Imports(as % of merchandise exports) of Europe(developing only) and Imports(as % of merchandise exports) of France?
Your answer should be very brief. 0.68. In the year 2003, what is the difference between the Imports(as % of merchandise exports) in Low & middle income and Imports(as % of merchandise exports) in Middle East & North Africa (all income levels)?
Your response must be concise. 1.01. In the year 2003, what is the difference between the Imports(as % of merchandise exports) of Low & middle income and Imports(as % of merchandise exports) of France?
Offer a terse response. 1.11. In the year 2003, what is the difference between the Imports(as % of merchandise exports) in Middle East & North Africa (all income levels) and Imports(as % of merchandise exports) in France?
Keep it short and to the point. 0.09. In the year 2004, what is the difference between the Imports(as % of merchandise exports) in Europe(developing only) and Imports(as % of merchandise exports) in Low & middle income?
Make the answer very short. -0.68. In the year 2004, what is the difference between the Imports(as % of merchandise exports) of Europe(developing only) and Imports(as % of merchandise exports) of Middle East & North Africa (all income levels)?
Your answer should be very brief. 0.33. In the year 2004, what is the difference between the Imports(as % of merchandise exports) in Europe(developing only) and Imports(as % of merchandise exports) in France?
Your answer should be compact. 0.49. In the year 2004, what is the difference between the Imports(as % of merchandise exports) of Low & middle income and Imports(as % of merchandise exports) of Middle East & North Africa (all income levels)?
Provide a succinct answer. 1.01. In the year 2004, what is the difference between the Imports(as % of merchandise exports) in Low & middle income and Imports(as % of merchandise exports) in France?
Offer a terse response. 1.17. In the year 2004, what is the difference between the Imports(as % of merchandise exports) of Middle East & North Africa (all income levels) and Imports(as % of merchandise exports) of France?
Your answer should be compact. 0.15. What is the ratio of the Imports(as % of merchandise exports) of Europe(developing only) in 1999 to that in 2000?
Offer a very short reply. 0.97. What is the ratio of the Imports(as % of merchandise exports) in Low & middle income in 1999 to that in 2000?
Give a very brief answer. 0.97. What is the ratio of the Imports(as % of merchandise exports) in Middle East & North Africa (all income levels) in 1999 to that in 2000?
Provide a succinct answer. 1.05. What is the ratio of the Imports(as % of merchandise exports) of Europe(developing only) in 1999 to that in 2001?
Provide a short and direct response. 0.94. What is the ratio of the Imports(as % of merchandise exports) of Low & middle income in 1999 to that in 2001?
Make the answer very short. 0.99. What is the ratio of the Imports(as % of merchandise exports) of Middle East & North Africa (all income levels) in 1999 to that in 2001?
Offer a terse response. 1.11. What is the ratio of the Imports(as % of merchandise exports) in France in 1999 to that in 2001?
Ensure brevity in your answer.  1.08. What is the ratio of the Imports(as % of merchandise exports) of Europe(developing only) in 1999 to that in 2002?
Give a very brief answer. 0.93. What is the ratio of the Imports(as % of merchandise exports) in Low & middle income in 1999 to that in 2002?
Your answer should be very brief. 1.07. What is the ratio of the Imports(as % of merchandise exports) in Middle East & North Africa (all income levels) in 1999 to that in 2002?
Your response must be concise. 1.01. What is the ratio of the Imports(as % of merchandise exports) of France in 1999 to that in 2002?
Offer a very short reply. 1.1. What is the ratio of the Imports(as % of merchandise exports) in Europe(developing only) in 1999 to that in 2003?
Offer a very short reply. 1.02. What is the ratio of the Imports(as % of merchandise exports) of Low & middle income in 1999 to that in 2003?
Give a very brief answer. 1.09. What is the ratio of the Imports(as % of merchandise exports) of Middle East & North Africa (all income levels) in 1999 to that in 2003?
Offer a very short reply. 0.94. What is the ratio of the Imports(as % of merchandise exports) of France in 1999 to that in 2003?
Your answer should be very brief. 1.1. What is the ratio of the Imports(as % of merchandise exports) of Europe(developing only) in 1999 to that in 2004?
Ensure brevity in your answer.  1.18. What is the ratio of the Imports(as % of merchandise exports) of Low & middle income in 1999 to that in 2004?
Provide a succinct answer. 1.11. What is the ratio of the Imports(as % of merchandise exports) in Middle East & North Africa (all income levels) in 1999 to that in 2004?
Keep it short and to the point. 0.97. What is the ratio of the Imports(as % of merchandise exports) in France in 1999 to that in 2004?
Your answer should be very brief. 1.18. What is the ratio of the Imports(as % of merchandise exports) in Europe(developing only) in 2000 to that in 2001?
Give a very brief answer. 0.97. What is the ratio of the Imports(as % of merchandise exports) in Low & middle income in 2000 to that in 2001?
Your answer should be compact. 1.02. What is the ratio of the Imports(as % of merchandise exports) of Middle East & North Africa (all income levels) in 2000 to that in 2001?
Your answer should be very brief. 1.06. What is the ratio of the Imports(as % of merchandise exports) of France in 2000 to that in 2001?
Provide a succinct answer. 1.12. What is the ratio of the Imports(as % of merchandise exports) in Europe(developing only) in 2000 to that in 2002?
Offer a terse response. 0.96. What is the ratio of the Imports(as % of merchandise exports) in Low & middle income in 2000 to that in 2002?
Ensure brevity in your answer.  1.1. What is the ratio of the Imports(as % of merchandise exports) in Middle East & North Africa (all income levels) in 2000 to that in 2002?
Provide a succinct answer. 0.97. What is the ratio of the Imports(as % of merchandise exports) in France in 2000 to that in 2002?
Keep it short and to the point. 1.14. What is the ratio of the Imports(as % of merchandise exports) in Europe(developing only) in 2000 to that in 2003?
Offer a very short reply. 1.05. What is the ratio of the Imports(as % of merchandise exports) in Low & middle income in 2000 to that in 2003?
Offer a terse response. 1.12. What is the ratio of the Imports(as % of merchandise exports) in Middle East & North Africa (all income levels) in 2000 to that in 2003?
Provide a succinct answer. 0.89. What is the ratio of the Imports(as % of merchandise exports) of France in 2000 to that in 2003?
Provide a short and direct response. 1.14. What is the ratio of the Imports(as % of merchandise exports) in Europe(developing only) in 2000 to that in 2004?
Make the answer very short. 1.21. What is the ratio of the Imports(as % of merchandise exports) of Low & middle income in 2000 to that in 2004?
Give a very brief answer. 1.15. What is the ratio of the Imports(as % of merchandise exports) of Middle East & North Africa (all income levels) in 2000 to that in 2004?
Your answer should be very brief. 0.92. What is the ratio of the Imports(as % of merchandise exports) of France in 2000 to that in 2004?
Make the answer very short. 1.23. What is the ratio of the Imports(as % of merchandise exports) in Europe(developing only) in 2001 to that in 2002?
Provide a succinct answer. 0.99. What is the ratio of the Imports(as % of merchandise exports) of Low & middle income in 2001 to that in 2002?
Your response must be concise. 1.08. What is the ratio of the Imports(as % of merchandise exports) in Middle East & North Africa (all income levels) in 2001 to that in 2002?
Provide a succinct answer. 0.91. What is the ratio of the Imports(as % of merchandise exports) in France in 2001 to that in 2002?
Your answer should be compact. 1.02. What is the ratio of the Imports(as % of merchandise exports) in Europe(developing only) in 2001 to that in 2003?
Ensure brevity in your answer.  1.08. What is the ratio of the Imports(as % of merchandise exports) in Low & middle income in 2001 to that in 2003?
Ensure brevity in your answer.  1.1. What is the ratio of the Imports(as % of merchandise exports) of Middle East & North Africa (all income levels) in 2001 to that in 2003?
Keep it short and to the point. 0.84. What is the ratio of the Imports(as % of merchandise exports) in France in 2001 to that in 2003?
Offer a terse response. 1.02. What is the ratio of the Imports(as % of merchandise exports) in Europe(developing only) in 2001 to that in 2004?
Your answer should be very brief. 1.25. What is the ratio of the Imports(as % of merchandise exports) in Low & middle income in 2001 to that in 2004?
Offer a very short reply. 1.13. What is the ratio of the Imports(as % of merchandise exports) of Middle East & North Africa (all income levels) in 2001 to that in 2004?
Ensure brevity in your answer.  0.87. What is the ratio of the Imports(as % of merchandise exports) in France in 2001 to that in 2004?
Your response must be concise. 1.1. What is the ratio of the Imports(as % of merchandise exports) of Europe(developing only) in 2002 to that in 2003?
Your response must be concise. 1.09. What is the ratio of the Imports(as % of merchandise exports) of Low & middle income in 2002 to that in 2003?
Your answer should be very brief. 1.02. What is the ratio of the Imports(as % of merchandise exports) of Middle East & North Africa (all income levels) in 2002 to that in 2003?
Offer a very short reply. 0.92. What is the ratio of the Imports(as % of merchandise exports) of France in 2002 to that in 2003?
Offer a very short reply. 1. What is the ratio of the Imports(as % of merchandise exports) of Europe(developing only) in 2002 to that in 2004?
Make the answer very short. 1.26. What is the ratio of the Imports(as % of merchandise exports) of Low & middle income in 2002 to that in 2004?
Your answer should be compact. 1.05. What is the ratio of the Imports(as % of merchandise exports) in Middle East & North Africa (all income levels) in 2002 to that in 2004?
Your answer should be compact. 0.95. What is the ratio of the Imports(as % of merchandise exports) of France in 2002 to that in 2004?
Make the answer very short. 1.08. What is the ratio of the Imports(as % of merchandise exports) of Europe(developing only) in 2003 to that in 2004?
Offer a very short reply. 1.15. What is the ratio of the Imports(as % of merchandise exports) in Low & middle income in 2003 to that in 2004?
Offer a terse response. 1.02. What is the ratio of the Imports(as % of merchandise exports) of Middle East & North Africa (all income levels) in 2003 to that in 2004?
Provide a succinct answer. 1.03. What is the ratio of the Imports(as % of merchandise exports) of France in 2003 to that in 2004?
Ensure brevity in your answer.  1.07. What is the difference between the highest and the second highest Imports(as % of merchandise exports) in Europe(developing only)?
Ensure brevity in your answer.  0.02. What is the difference between the highest and the second highest Imports(as % of merchandise exports) in Low & middle income?
Ensure brevity in your answer.  0.06. What is the difference between the highest and the second highest Imports(as % of merchandise exports) in Middle East & North Africa (all income levels)?
Provide a short and direct response. 0.06. What is the difference between the highest and the second highest Imports(as % of merchandise exports) of France?
Keep it short and to the point. 0.06. What is the difference between the highest and the lowest Imports(as % of merchandise exports) of Europe(developing only)?
Ensure brevity in your answer.  0.53. What is the difference between the highest and the lowest Imports(as % of merchandise exports) in Low & middle income?
Your response must be concise. 0.4. What is the difference between the highest and the lowest Imports(as % of merchandise exports) of Middle East & North Africa (all income levels)?
Provide a succinct answer. 0.28. What is the difference between the highest and the lowest Imports(as % of merchandise exports) of France?
Make the answer very short. 0.35. 